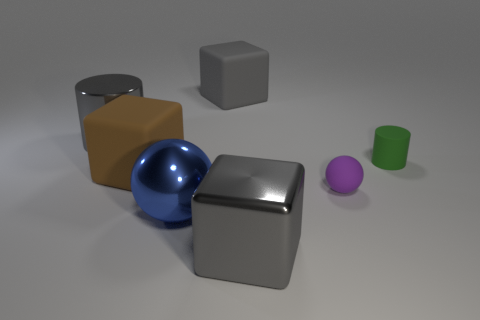Are there any other things that are the same size as the blue sphere?
Offer a very short reply. Yes. Are there fewer gray cubes left of the brown block than big matte blocks that are in front of the big gray cylinder?
Your answer should be very brief. Yes. Is there any other thing that is the same shape as the gray rubber thing?
Provide a succinct answer. Yes. What material is the large cylinder that is the same color as the metal cube?
Offer a terse response. Metal. How many small purple balls are to the left of the matte cube that is to the left of the large gray block behind the small purple rubber object?
Ensure brevity in your answer.  0. How many large gray cubes are in front of the green matte cylinder?
Offer a terse response. 1. What number of small green cylinders have the same material as the big brown object?
Give a very brief answer. 1. What is the color of the tiny cylinder that is the same material as the small purple ball?
Offer a terse response. Green. The gray block that is in front of the gray object to the left of the big matte block that is right of the big blue shiny sphere is made of what material?
Offer a very short reply. Metal. Do the gray object in front of the matte cylinder and the brown block have the same size?
Your answer should be very brief. Yes. 